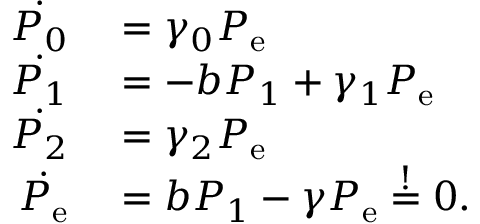Convert formula to latex. <formula><loc_0><loc_0><loc_500><loc_500>\begin{array} { r l } { \dot { P _ { 0 } } } & = \gamma _ { 0 } P _ { e } } \\ { \dot { P _ { 1 } } } & = - b P _ { 1 } + \gamma _ { 1 } P _ { e } } \\ { \dot { P _ { 2 } } } & = \gamma _ { 2 } P _ { e } } \\ { \dot { P _ { e } } } & = b P _ { 1 } - \gamma P _ { e } \overset { ! } { = } 0 . } \end{array}</formula> 